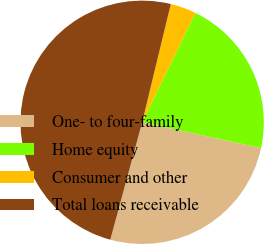<chart> <loc_0><loc_0><loc_500><loc_500><pie_chart><fcel>One- to four-family<fcel>Home equity<fcel>Consumer and other<fcel>Total loans receivable<nl><fcel>25.81%<fcel>21.2%<fcel>3.42%<fcel>49.57%<nl></chart> 